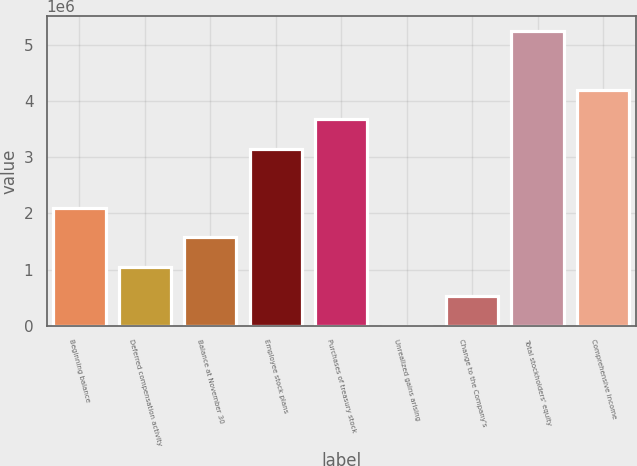<chart> <loc_0><loc_0><loc_500><loc_500><bar_chart><fcel>Beginning balance<fcel>Deferred compensation activity<fcel>Balance at November 30<fcel>Employee stock plans<fcel>Purchases of treasury stock<fcel>Unrealized gains arising<fcel>Change to the Company's<fcel>Total stockholders' equity<fcel>Comprehensive income<nl><fcel>2.10068e+06<fcel>1.05043e+06<fcel>1.57555e+06<fcel>3.15092e+06<fcel>3.67604e+06<fcel>185<fcel>525308<fcel>5.25141e+06<fcel>4.20117e+06<nl></chart> 